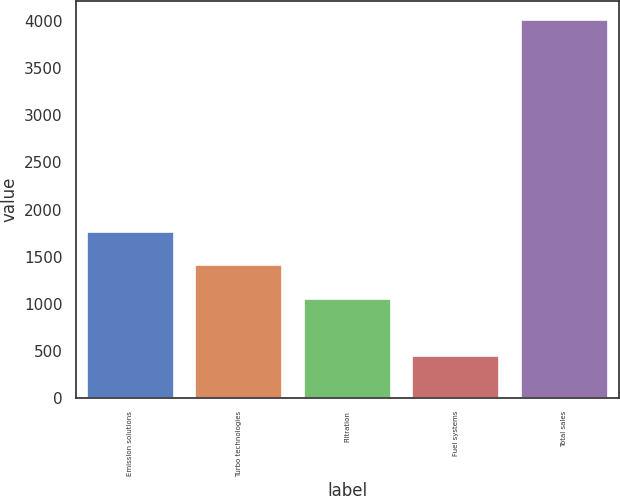Convert chart to OTSL. <chart><loc_0><loc_0><loc_500><loc_500><bar_chart><fcel>Emission solutions<fcel>Turbo technologies<fcel>Filtration<fcel>Fuel systems<fcel>Total sales<nl><fcel>1761.8<fcel>1404.9<fcel>1048<fcel>443<fcel>4012<nl></chart> 